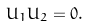<formula> <loc_0><loc_0><loc_500><loc_500>U _ { 1 } U _ { 2 } = 0 .</formula> 